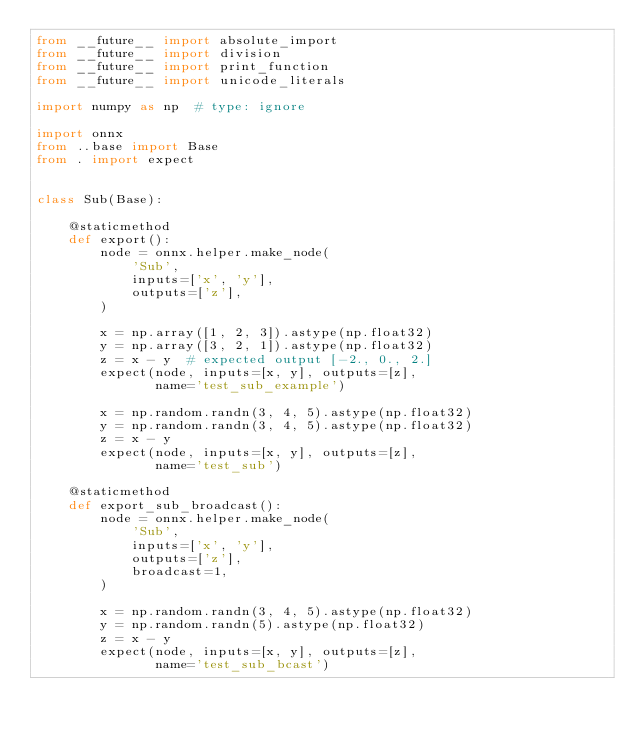Convert code to text. <code><loc_0><loc_0><loc_500><loc_500><_Python_>from __future__ import absolute_import
from __future__ import division
from __future__ import print_function
from __future__ import unicode_literals

import numpy as np  # type: ignore

import onnx
from ..base import Base
from . import expect


class Sub(Base):

    @staticmethod
    def export():
        node = onnx.helper.make_node(
            'Sub',
            inputs=['x', 'y'],
            outputs=['z'],
        )

        x = np.array([1, 2, 3]).astype(np.float32)
        y = np.array([3, 2, 1]).astype(np.float32)
        z = x - y  # expected output [-2., 0., 2.]
        expect(node, inputs=[x, y], outputs=[z],
               name='test_sub_example')

        x = np.random.randn(3, 4, 5).astype(np.float32)
        y = np.random.randn(3, 4, 5).astype(np.float32)
        z = x - y
        expect(node, inputs=[x, y], outputs=[z],
               name='test_sub')

    @staticmethod
    def export_sub_broadcast():
        node = onnx.helper.make_node(
            'Sub',
            inputs=['x', 'y'],
            outputs=['z'],
            broadcast=1,
        )

        x = np.random.randn(3, 4, 5).astype(np.float32)
        y = np.random.randn(5).astype(np.float32)
        z = x - y
        expect(node, inputs=[x, y], outputs=[z],
               name='test_sub_bcast')
</code> 